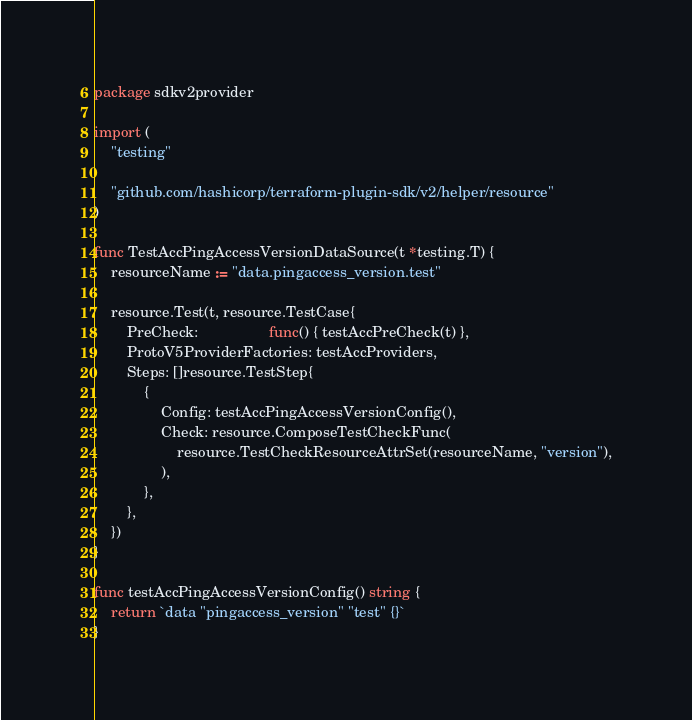<code> <loc_0><loc_0><loc_500><loc_500><_Go_>package sdkv2provider

import (
	"testing"

	"github.com/hashicorp/terraform-plugin-sdk/v2/helper/resource"
)

func TestAccPingAccessVersionDataSource(t *testing.T) {
	resourceName := "data.pingaccess_version.test"

	resource.Test(t, resource.TestCase{
		PreCheck:                 func() { testAccPreCheck(t) },
		ProtoV5ProviderFactories: testAccProviders,
		Steps: []resource.TestStep{
			{
				Config: testAccPingAccessVersionConfig(),
				Check: resource.ComposeTestCheckFunc(
					resource.TestCheckResourceAttrSet(resourceName, "version"),
				),
			},
		},
	})
}

func testAccPingAccessVersionConfig() string {
	return `data "pingaccess_version" "test" {}`
}
</code> 